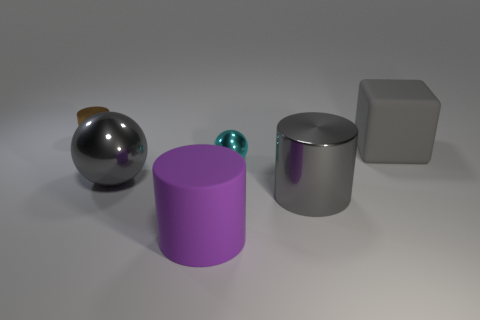What number of purple objects are the same size as the gray cube?
Offer a very short reply. 1. What shape is the cyan thing that is the same material as the gray ball?
Your answer should be very brief. Sphere. Are there any large cylinders of the same color as the block?
Offer a terse response. Yes. What is the brown cylinder made of?
Your response must be concise. Metal. What number of objects are brown things or cylinders?
Offer a terse response. 3. There is a cylinder that is behind the large gray cylinder; how big is it?
Your response must be concise. Small. How many other things are made of the same material as the gray cylinder?
Give a very brief answer. 3. Are there any big purple cylinders that are right of the small brown metal cylinder that is behind the gray cylinder?
Your answer should be compact. Yes. Are there any other things that have the same shape as the small brown thing?
Your answer should be compact. Yes. The large object that is the same shape as the small cyan shiny thing is what color?
Your answer should be very brief. Gray. 